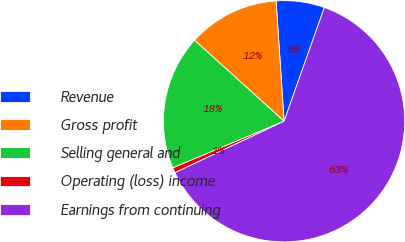Convert chart to OTSL. <chart><loc_0><loc_0><loc_500><loc_500><pie_chart><fcel>Revenue<fcel>Gross profit<fcel>Selling general and<fcel>Operating (loss) income<fcel>Earnings from continuing<nl><fcel>6.47%<fcel>12.25%<fcel>18.02%<fcel>0.7%<fcel>62.56%<nl></chart> 